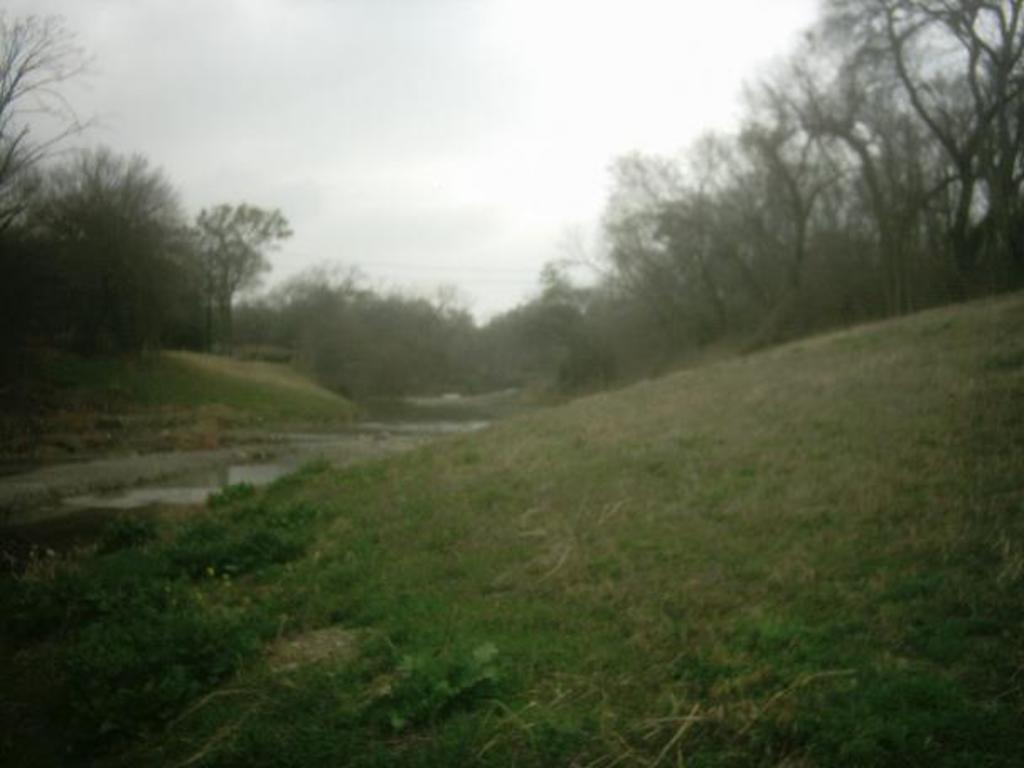What type of vegetation is at the bottom of the image? There is grass at the bottom of the image. What body of water is on the left side of the image? There is a pond on the left side of the image. What can be seen in the background of the image? There are trees, plants, and grass in the background of the image. What is visible at the top of the image? The sky is visible at the top of the image. What type of coast can be seen in the image? There is no coast present in the image; it features a pond, grass, trees, plants, and the sky. What color are the teeth of the plants in the image? There are no teeth present in the image, as plants do not have teeth. 